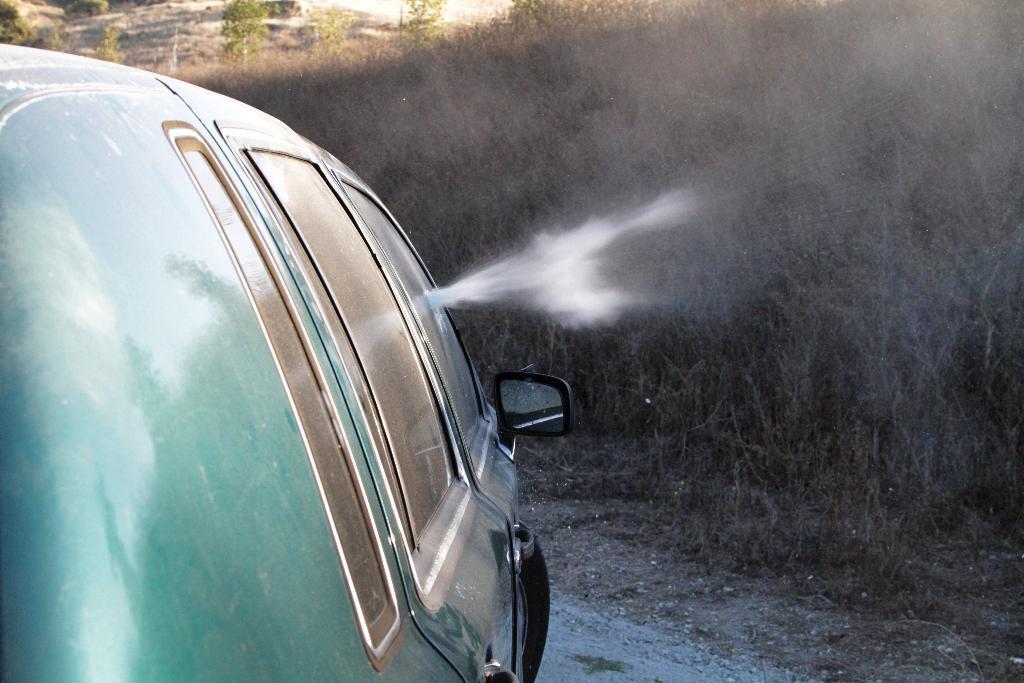Can you describe this image briefly? In this image there is a car on the ground. There are glass windows and a mirror to the car. Behind the car there are plants on the ground. 